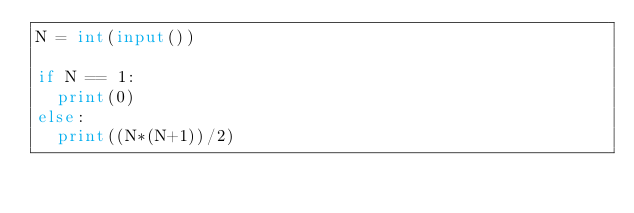Convert code to text. <code><loc_0><loc_0><loc_500><loc_500><_Python_>N = int(input())

if N == 1:
  print(0)
else:
  print((N*(N+1))/2)</code> 